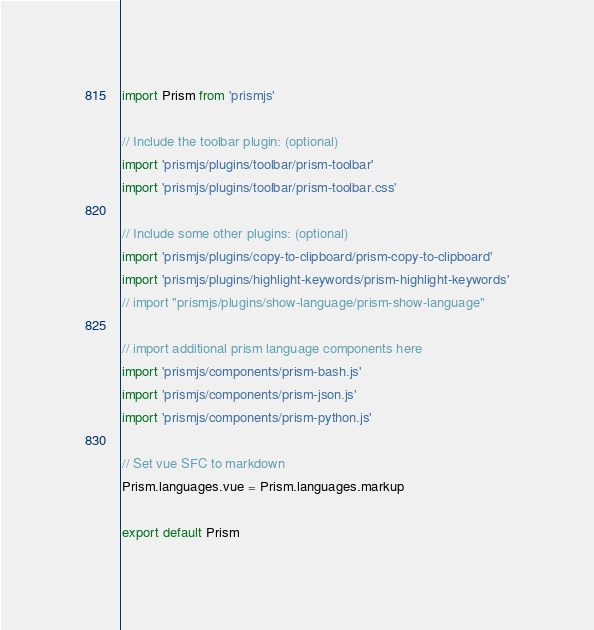<code> <loc_0><loc_0><loc_500><loc_500><_JavaScript_>import Prism from 'prismjs'

// Include the toolbar plugin: (optional)
import 'prismjs/plugins/toolbar/prism-toolbar'
import 'prismjs/plugins/toolbar/prism-toolbar.css'

// Include some other plugins: (optional)
import 'prismjs/plugins/copy-to-clipboard/prism-copy-to-clipboard'
import 'prismjs/plugins/highlight-keywords/prism-highlight-keywords'
// import "prismjs/plugins/show-language/prism-show-language"

// import additional prism language components here
import 'prismjs/components/prism-bash.js'
import 'prismjs/components/prism-json.js'
import 'prismjs/components/prism-python.js'

// Set vue SFC to markdown
Prism.languages.vue = Prism.languages.markup

export default Prism
</code> 